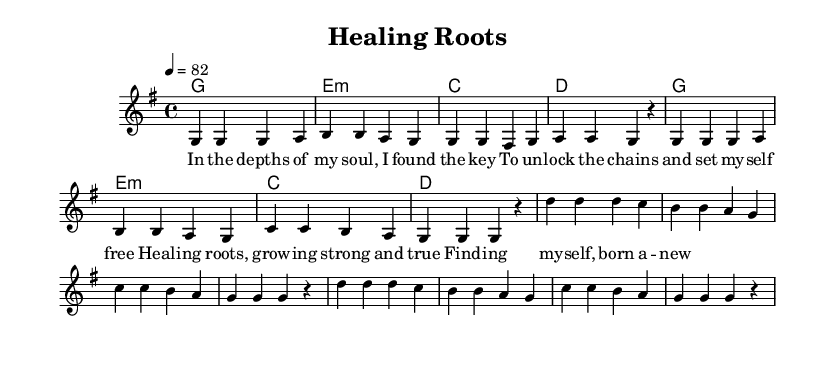What is the key signature of this music? The key signature indicated is G major, which has one sharp (F#). This can be identified in the global music section.
Answer: G major What is the time signature of this music? The time signature is 4/4, as noted in the global section. This means there are four beats in each measure.
Answer: 4/4 What is the tempo marking for this music? The tempo marking is indicated as "4 = 82," meaning there are 82 beats per minute. This is found in the global section of the score.
Answer: 82 How many measures are there in the verse? The verse consists of 8 measures. By counting each group of notes segmented by the vertical lines, we find 8 distinct measures.
Answer: 8 What is the main theme addressed in the lyrics? The main theme is about healing and self-discovery, as expressed through the words in the verse and chorus. This can be inferred from the emotional content of the lyrics.
Answer: Healing and self-discovery Which chord is used in the first measure? The first measure's chord is G major, as indicated in the harmonies section where the first chord is written.
Answer: G What aspect of music makes this piece reggae? The rhythmic feel and the uplifting nature of the lyrics characterize it as reggae. The syncopated rhythm and upbeat tempo are also key elements typical of this genre.
Answer: Rhythmic feel 